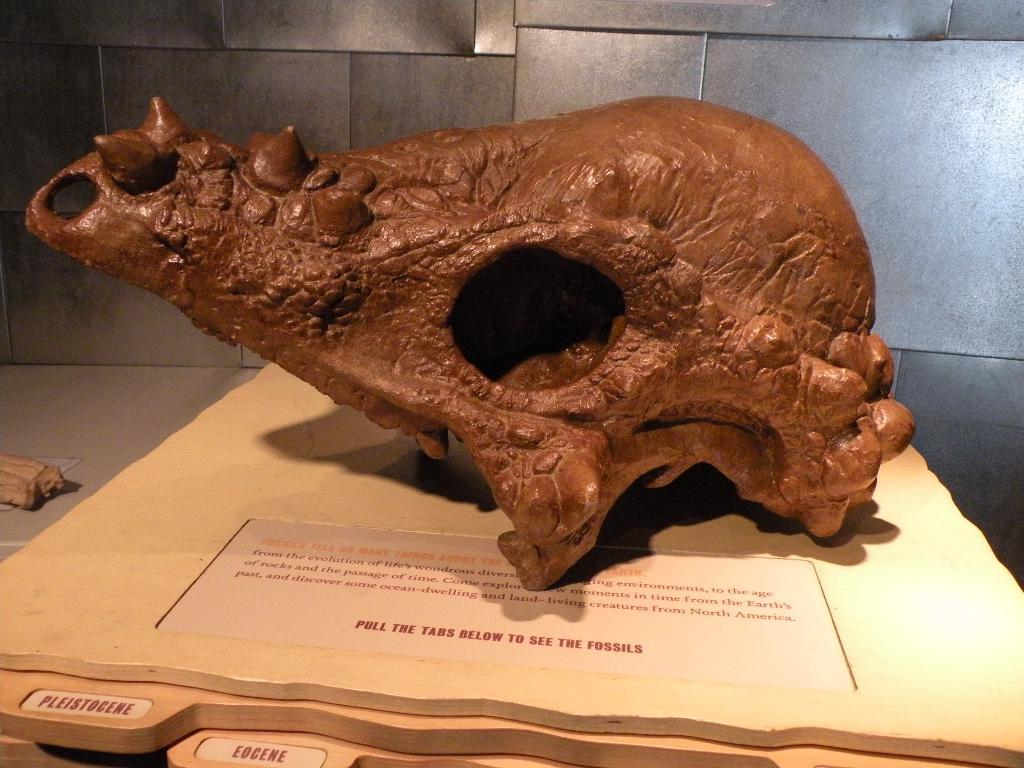What is the main subject of the image? There is a fossil in the image. Where is the fossil located? The fossil is placed on a table. What can be seen in the background of the image? There is a wall in the background of the image. What type of temper does the fossil have in the image? The fossil does not have a temper, as it is an inanimate object. 